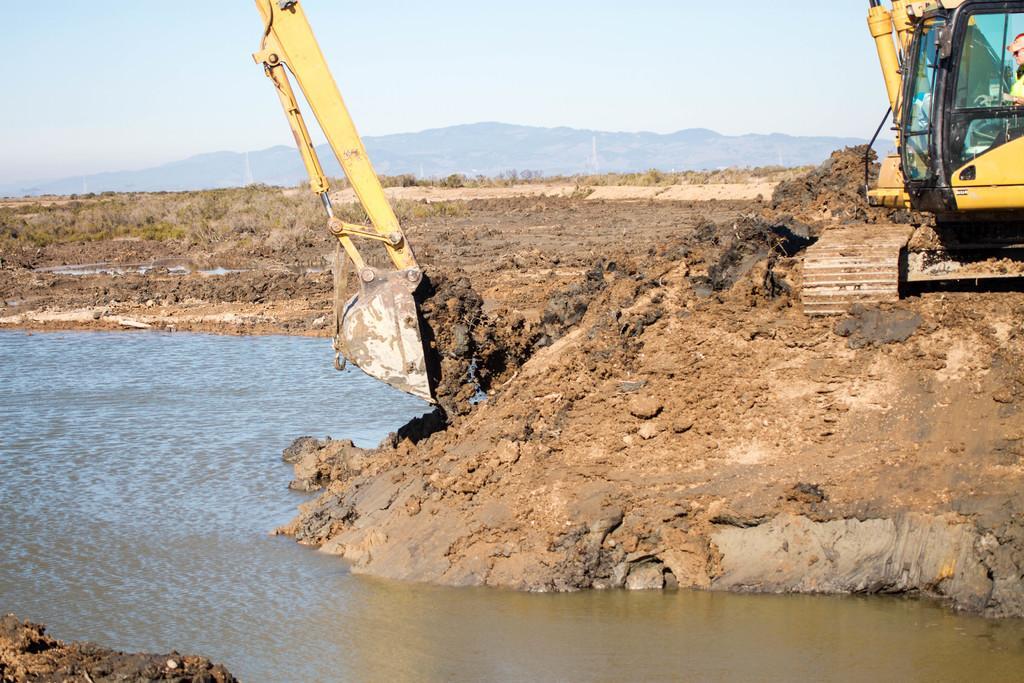Describe this image in one or two sentences. At the bottom of the image there is a lake. On the right we can see a crane excavating. In the background there is a hill and sky. 